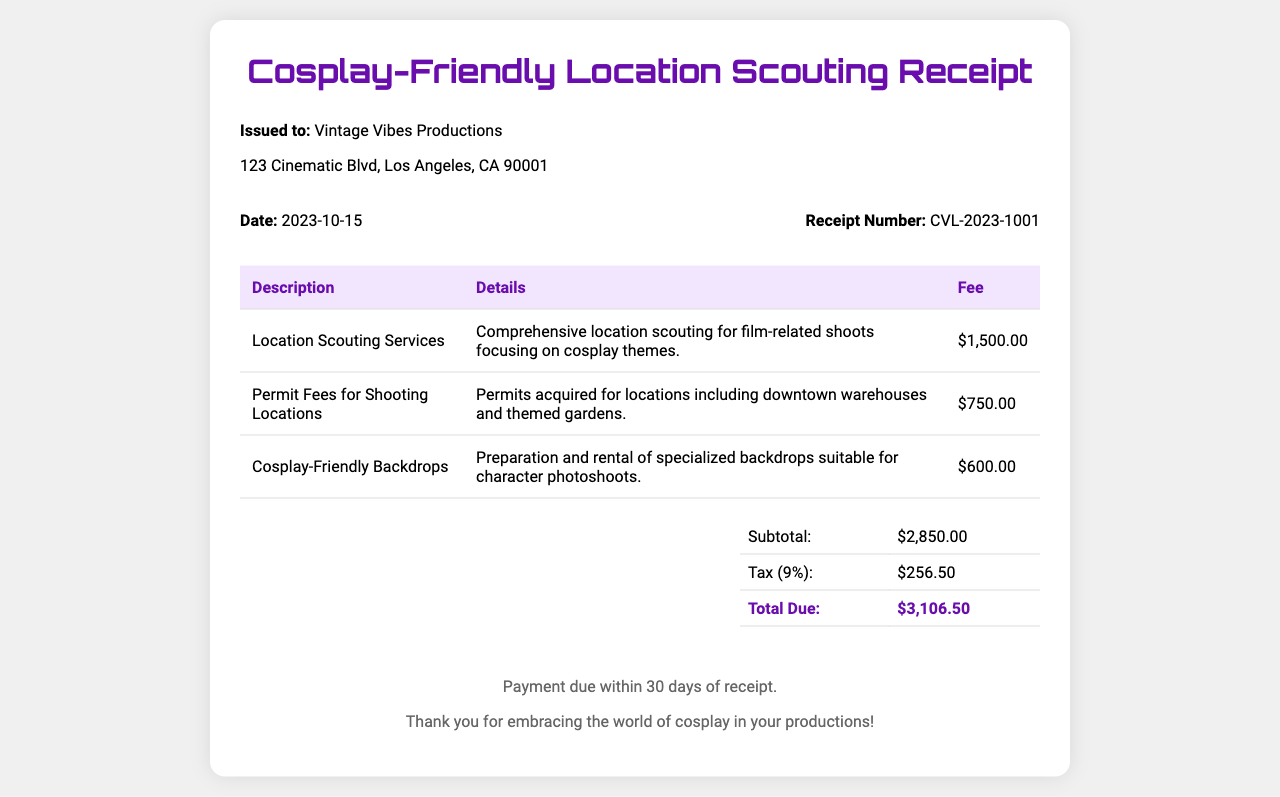What is the total due? The total due is found in the total section of the document, which states the total amount payable.
Answer: $3,106.50 What is the date of the receipt? The date can be found in the receipt details section, specifying when the receipt was issued.
Answer: 2023-10-15 Who is the receipt issued to? The issuer's name is located in the company info section of the receipt.
Answer: Vintage Vibes Productions What is the fee for permit fees? The fee for permit fees can be found in the table under the corresponding description.
Answer: $750.00 How much were the cosplay-friendly backdrops? The amount for cosplay-friendly backdrops is specified in the third row of the fees section.
Answer: $600.00 What was the subtotal amount? The subtotal is shown in the total section of the document and is before tax.
Answer: $2,850.00 What is the tax percentage applied? The tax percentage is noted in the total section detailing how tax was calculated.
Answer: 9% What type of services were provided? The type of services is detailed in the first row under description in the fees table.
Answer: Location Scouting Services What is the address of the company? The address of the company is listed in the company info section of the document.
Answer: 123 Cinematic Blvd, Los Angeles, CA 90001 